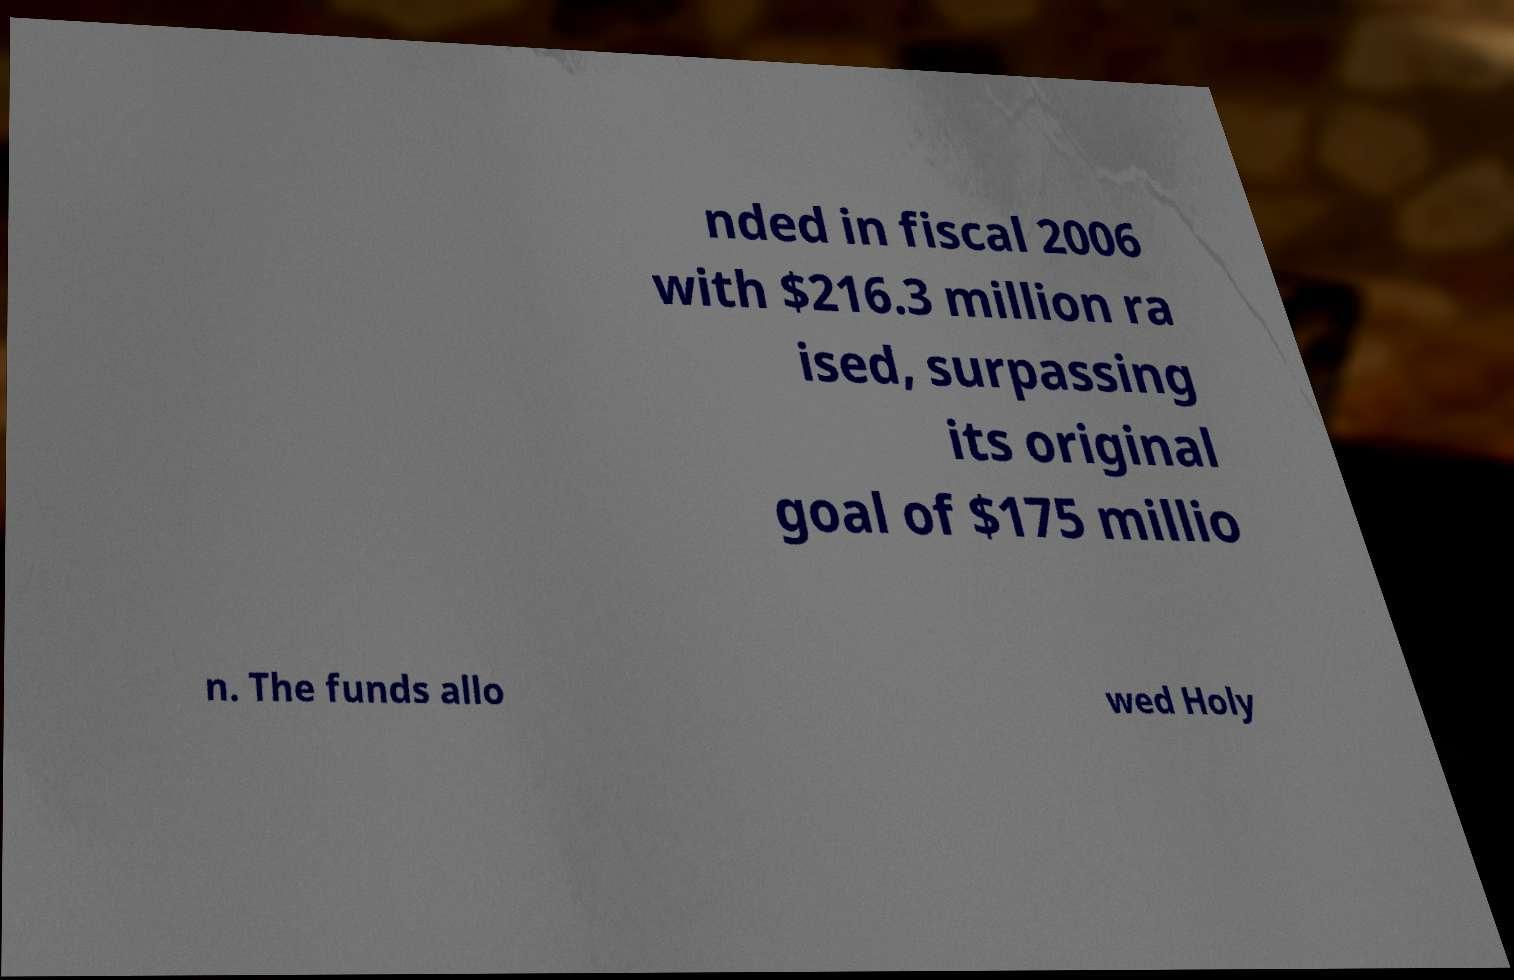What messages or text are displayed in this image? I need them in a readable, typed format. nded in fiscal 2006 with $216.3 million ra ised, surpassing its original goal of $175 millio n. The funds allo wed Holy 